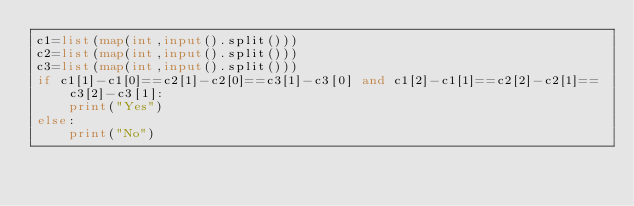Convert code to text. <code><loc_0><loc_0><loc_500><loc_500><_Python_>c1=list(map(int,input().split()))
c2=list(map(int,input().split()))
c3=list(map(int,input().split()))
if c1[1]-c1[0]==c2[1]-c2[0]==c3[1]-c3[0] and c1[2]-c1[1]==c2[2]-c2[1]==c3[2]-c3[1]:
    print("Yes")
else:
    print("No")</code> 